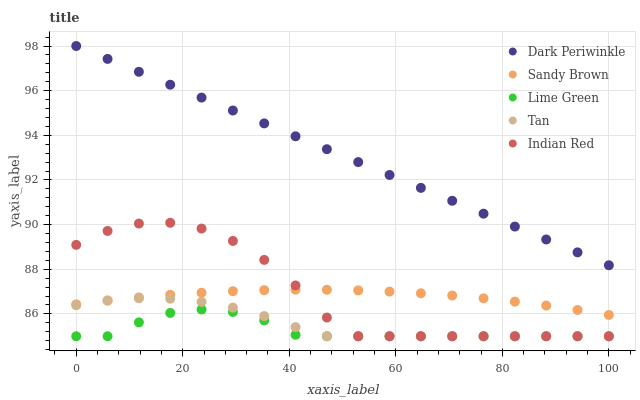Does Lime Green have the minimum area under the curve?
Answer yes or no. Yes. Does Dark Periwinkle have the maximum area under the curve?
Answer yes or no. Yes. Does Tan have the minimum area under the curve?
Answer yes or no. No. Does Tan have the maximum area under the curve?
Answer yes or no. No. Is Dark Periwinkle the smoothest?
Answer yes or no. Yes. Is Indian Red the roughest?
Answer yes or no. Yes. Is Tan the smoothest?
Answer yes or no. No. Is Tan the roughest?
Answer yes or no. No. Does Lime Green have the lowest value?
Answer yes or no. Yes. Does Sandy Brown have the lowest value?
Answer yes or no. No. Does Dark Periwinkle have the highest value?
Answer yes or no. Yes. Does Tan have the highest value?
Answer yes or no. No. Is Lime Green less than Sandy Brown?
Answer yes or no. Yes. Is Dark Periwinkle greater than Lime Green?
Answer yes or no. Yes. Does Tan intersect Lime Green?
Answer yes or no. Yes. Is Tan less than Lime Green?
Answer yes or no. No. Is Tan greater than Lime Green?
Answer yes or no. No. Does Lime Green intersect Sandy Brown?
Answer yes or no. No. 